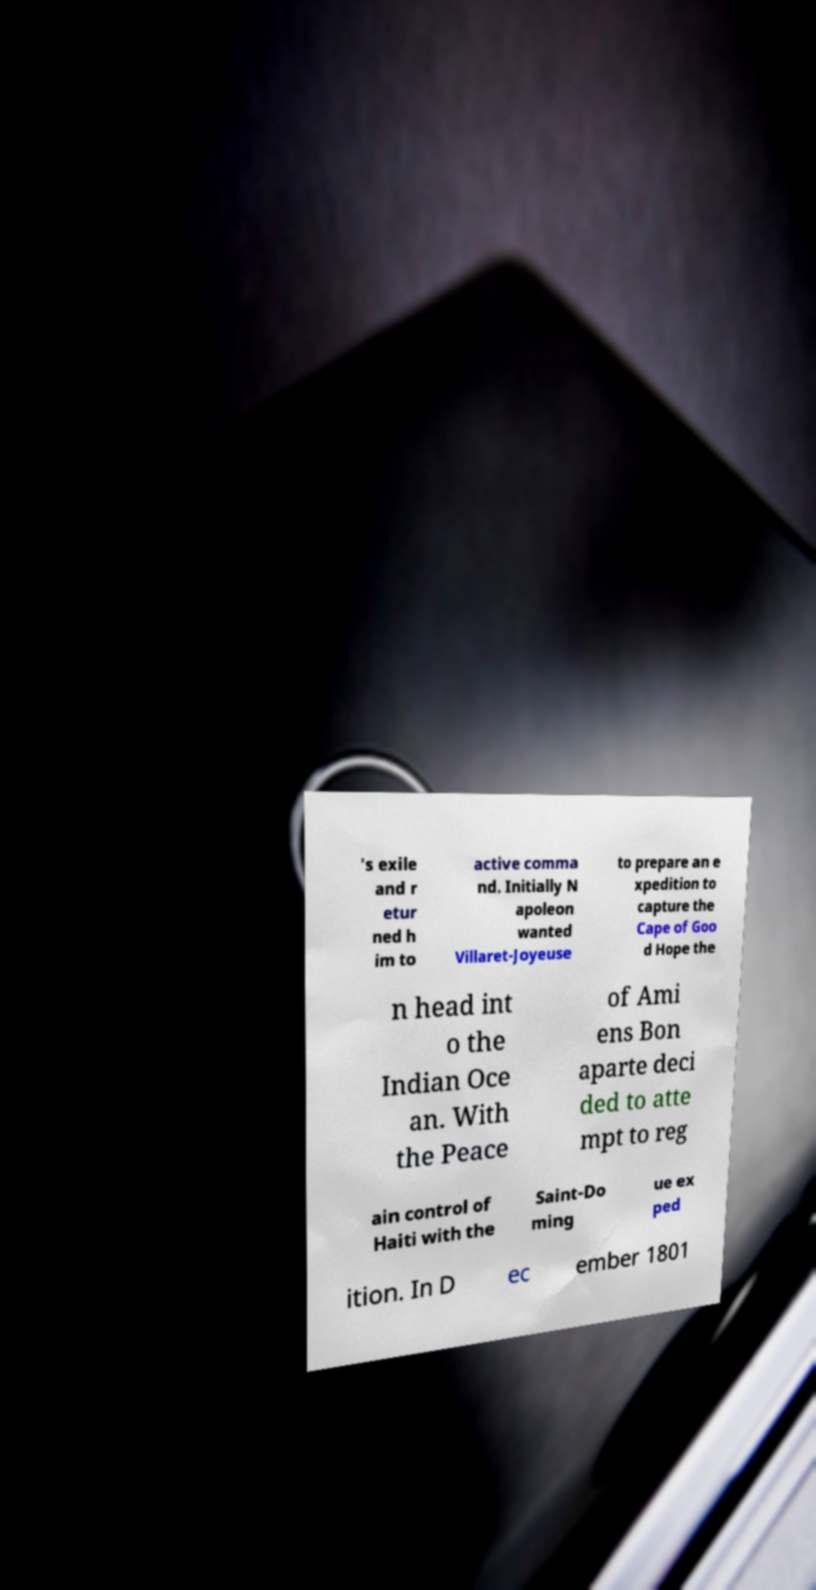Could you extract and type out the text from this image? 's exile and r etur ned h im to active comma nd. Initially N apoleon wanted Villaret-Joyeuse to prepare an e xpedition to capture the Cape of Goo d Hope the n head int o the Indian Oce an. With the Peace of Ami ens Bon aparte deci ded to atte mpt to reg ain control of Haiti with the Saint-Do ming ue ex ped ition. In D ec ember 1801 